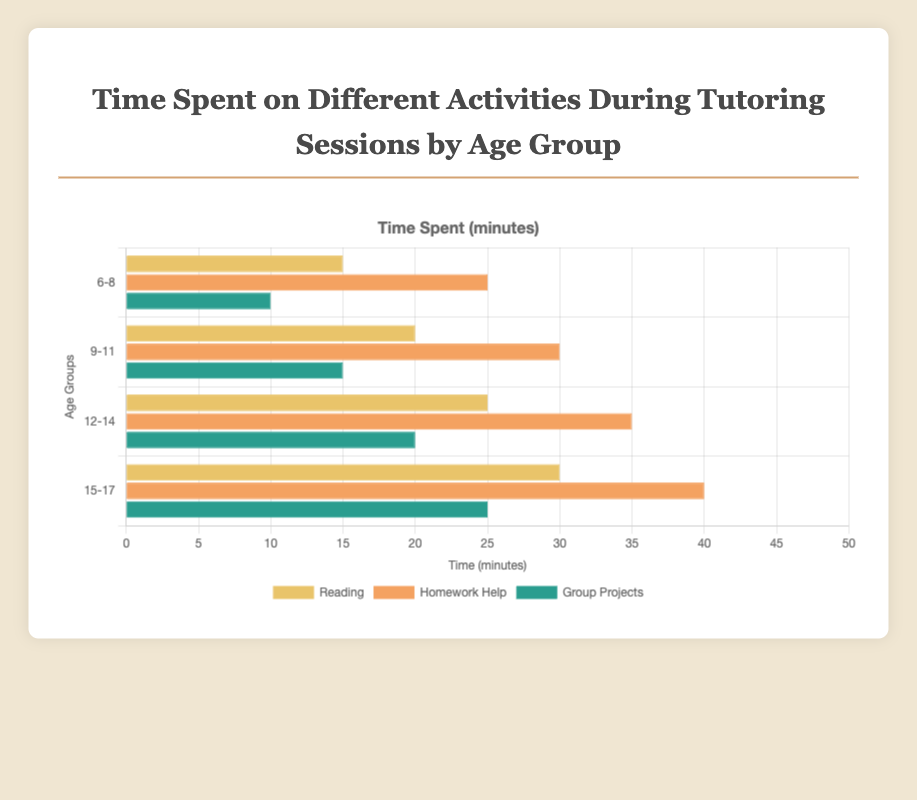Which activity takes the most time overall across all age groups? Summing up the time spent on Reading, Homework Help, and Group Projects for all age groups: Reading (15 + 20 + 25 + 30) = 90, Homework Help (25 + 30 + 35 + 40) = 130, Group Projects (10 + 15 + 20 + 25) = 70. Homework Help has the highest total.
Answer: Homework Help In the age group 9-11, which activity has the least time spent? Referring to the '9-11' age group, Reading = 20, Homework Help = 30, and Group Projects = 15. Group Projects has the least time spent.
Answer: Group Projects How much more time do 15-17-year-olds spend on Reading compared to 6-8-year-olds? Comparing the time for Reading: 15-17-year-olds = 30, 6-8-year-olds = 15. Time difference is 30 - 15 = 15 minutes.
Answer: 15 minutes What is the total time spent on Group Projects across all age groups? Summing up the time spent on Group Projects for all age groups: 10 (6-8) + 15 (9-11) + 20 (12-14) + 25 (15-17) = 70 minutes.
Answer: 70 minutes Which age group spends the most time on Homework Help? Checking the time spent on Homework Help for each age group: 6-8 = 25, 9-11 = 30, 12-14 = 35, 15-17 = 40. The age group 15-17 spends the most time.
Answer: 15-17 What is the average time spent on Reading by all age groups? Summing the time spent on Reading and dividing by the number of age groups: (15 + 20 + 25 + 30) / 4 = 90 / 4 = 22.5 minutes.
Answer: 22.5 minutes For the age group 12-14, what is the difference in time spent between Homework Help and Group Projects? Comparing times for the '12-14' group: Homework Help = 35, Group Projects = 20. Difference is 35 - 20 = 15 minutes.
Answer: 15 minutes Which activity shows a consistent increase in time spent as age increases? Observing the data: Reading (15, 20, 25, 30), Homework Help (25, 30, 35, 40), Group Projects (10, 15, 20, 25). All activities show consistent increases, but a closer analysis reveals the pattern.
Answer: All activities 